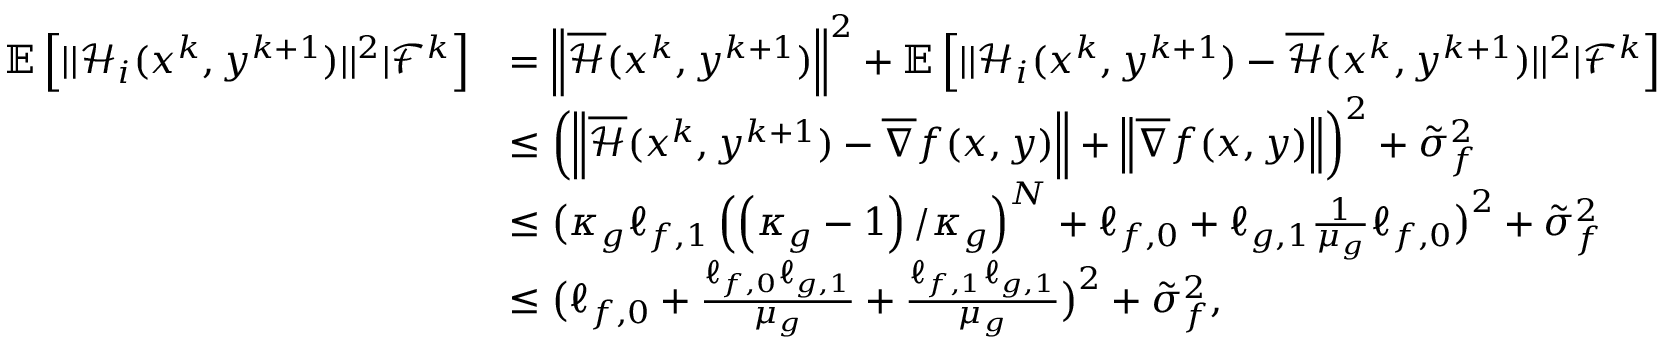<formula> <loc_0><loc_0><loc_500><loc_500>\begin{array} { r l } { \mathbb { E } \left [ | | \mathcal { H } _ { i } ( x ^ { k } , y ^ { k + 1 } ) | | ^ { 2 } | \mathcal { F } ^ { k } \right ] } & { = \left \| \overline { { \mathcal { H } } } ( x ^ { k } , y ^ { k + 1 } ) \right \| ^ { 2 } + \mathbb { E } \left [ | | \mathcal { H } _ { i } ( x ^ { k } , y ^ { k + 1 } ) - \overline { { \mathcal { H } } } ( x ^ { k } , y ^ { k + 1 } ) | | ^ { 2 } | \mathcal { F } ^ { k } \right ] } \\ & { \leq \left ( \left \| \overline { { \mathcal { H } } } ( x ^ { k } , y ^ { k + 1 } ) - \overline { \nabla } f ( x , y ) \right \| + \left \| \overline { \nabla } f ( x , y ) \right \| \right ) ^ { 2 } + \tilde { \sigma } _ { f } ^ { 2 } } \\ & { \leq \left ( \kappa _ { g } \ell _ { f , 1 } \left ( \left ( \kappa _ { g } - 1 \right ) / \kappa _ { g } \right ) ^ { N } + \ell _ { f , 0 } + \ell _ { g , 1 } \frac { 1 } { \mu _ { g } } \ell _ { f , 0 } \right ) ^ { 2 } + \tilde { \sigma } _ { f } ^ { 2 } } \\ & { \leq \left ( \ell _ { f , 0 } + \frac { \ell _ { f , 0 } \ell _ { g , 1 } } { \mu _ { g } } + \frac { \ell _ { f , 1 } \ell _ { g , 1 } } { \mu _ { g } } \right ) ^ { 2 } + \tilde { \sigma } _ { f } ^ { 2 } , } \end{array}</formula> 